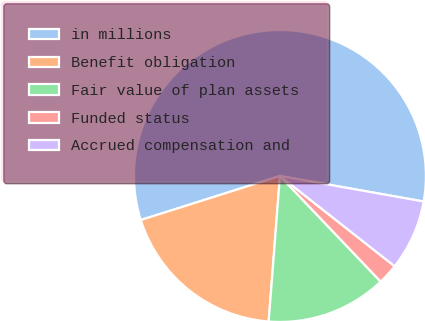Convert chart to OTSL. <chart><loc_0><loc_0><loc_500><loc_500><pie_chart><fcel>in millions<fcel>Benefit obligation<fcel>Fair value of plan assets<fcel>Funded status<fcel>Accrued compensation and<nl><fcel>57.68%<fcel>18.89%<fcel>13.35%<fcel>2.27%<fcel>7.81%<nl></chart> 